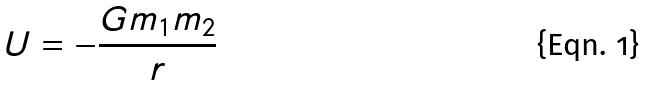<formula> <loc_0><loc_0><loc_500><loc_500>U = - \frac { G m _ { 1 } m _ { 2 } } { r }</formula> 